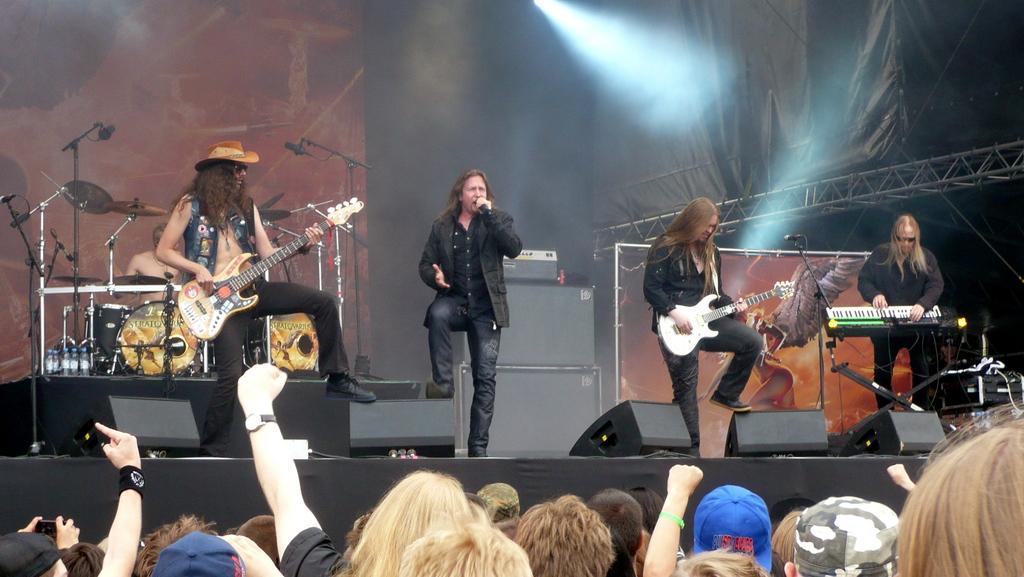Could you give a brief overview of what you see in this image? In the image we can see five persons were on the stage and holding guitar. The center person he is holding microphone. In the bottom we can see group of persons were standing,they were audience. In the background there is a wall,sheet,speaker,water bottle and few musical instruments. 